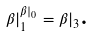<formula> <loc_0><loc_0><loc_500><loc_500>\beta | _ { 1 } ^ { \beta | _ { 0 } } = \beta | _ { 3 } \text {.}</formula> 